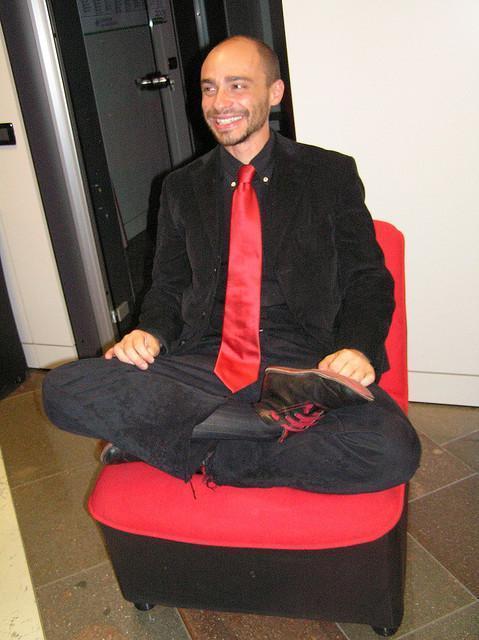How many chairs are there?
Give a very brief answer. 1. 